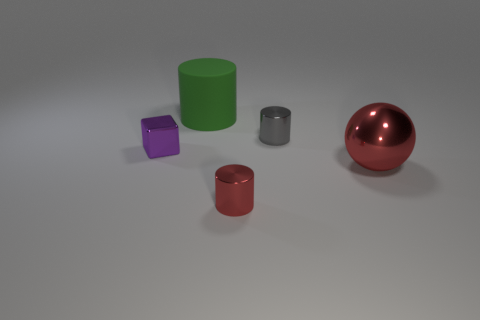There is a red cylinder that is the same material as the purple thing; what is its size?
Your answer should be very brief. Small. There is a red thing to the left of the large thing that is on the right side of the green cylinder; what number of small red objects are in front of it?
Give a very brief answer. 0. There is a shiny block; does it have the same color as the cylinder that is in front of the big red thing?
Make the answer very short. No. There is a small thing that is the same color as the shiny sphere; what shape is it?
Offer a terse response. Cylinder. The tiny thing that is in front of the large object that is in front of the big object behind the block is made of what material?
Offer a terse response. Metal. Is the shape of the large thing behind the big red sphere the same as  the small purple thing?
Your response must be concise. No. What is the tiny cylinder that is in front of the tiny gray cylinder made of?
Ensure brevity in your answer.  Metal. What number of rubber things are either small gray cylinders or big brown objects?
Make the answer very short. 0. Are there any red shiny objects of the same size as the metallic sphere?
Offer a terse response. No. Is the number of green matte things on the left side of the tiny gray cylinder greater than the number of big green metal cylinders?
Your response must be concise. Yes. 